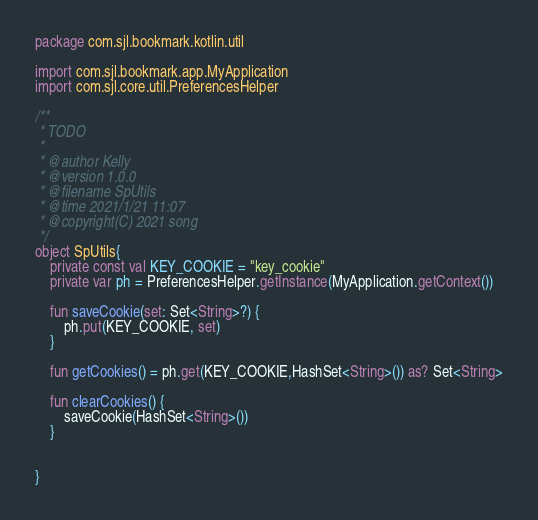Convert code to text. <code><loc_0><loc_0><loc_500><loc_500><_Kotlin_>package com.sjl.bookmark.kotlin.util

import com.sjl.bookmark.app.MyApplication
import com.sjl.core.util.PreferencesHelper

/**
 * TODO
 *
 * @author Kelly
 * @version 1.0.0
 * @filename SpUtils
 * @time 2021/1/21 11:07
 * @copyright(C) 2021 song
 */
object SpUtils{
    private const val KEY_COOKIE = "key_cookie"
    private var ph = PreferencesHelper.getInstance(MyApplication.getContext())

    fun saveCookie(set: Set<String>?) {
        ph.put(KEY_COOKIE, set)
    }

    fun getCookies() = ph.get(KEY_COOKIE,HashSet<String>()) as? Set<String>

    fun clearCookies() {
        saveCookie(HashSet<String>())
    }


}

</code> 